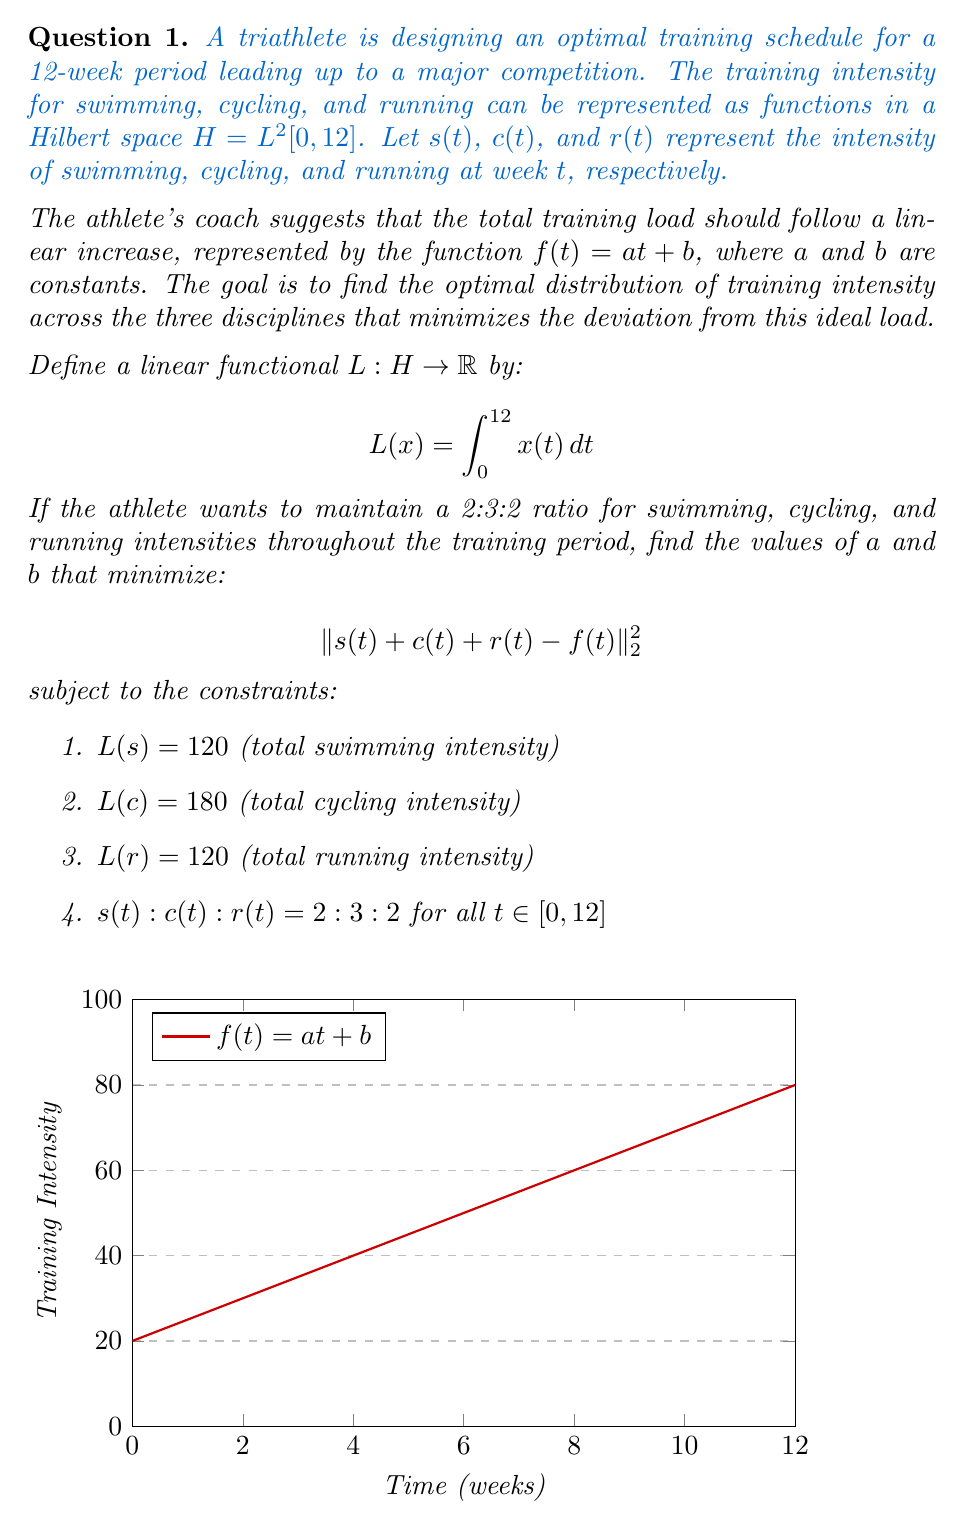Provide a solution to this math problem. Let's approach this step-by-step:

1) First, we need to express $s(t)$, $c(t)$, and $r(t)$ in terms of a single function due to the ratio constraint:
   Let $x(t)$ be our base function.
   Then, $s(t) = 2x(t)$, $c(t) = 3x(t)$, and $r(t) = 2x(t)$

2) Now, we can rewrite our constraints:
   $L(2x) = 120$, $L(3x) = 180$, $L(2x) = 120$

3) Using the linearity of $L$, we get:
   $2L(x) = 120$, $3L(x) = 180$, $2L(x) = 120$
   
   These are consistent and give us: $L(x) = 60$

4) Now, $L(x) = \int_0^{12} x(t) \, dt = 60$

5) The function we want to minimize becomes:
   $\| 2x(t) + 3x(t) + 2x(t) - (at + b) \|_2^2 = \| 7x(t) - (at + b) \|_2^2$

6) For this to be minimized, we need:
   $7x(t) = at + b$

7) Integrating both sides from 0 to 12:
   $7 \int_0^{12} x(t) \, dt = \int_0^{12} (at + b) \, dt$
   $7(60) = a(12^2/2) + 12b$
   $420 = 72a + 12b$

8) We also know that $x(t) = (at + b)/7$, so:
   $\int_0^{12} x(t) \, dt = \int_0^{12} (at + b)/7 \, dt = 60$
   $(a(12^2/2) + 12b)/7 = 60$
   $72a + 12b = 420$

9) From steps 7 and 8, we have two identical equations. Solving this:
   $a = 5$ and $b = 20$

Therefore, the optimal training load function is $f(t) = 5t + 20$.
Answer: $a = 5$, $b = 20$ 